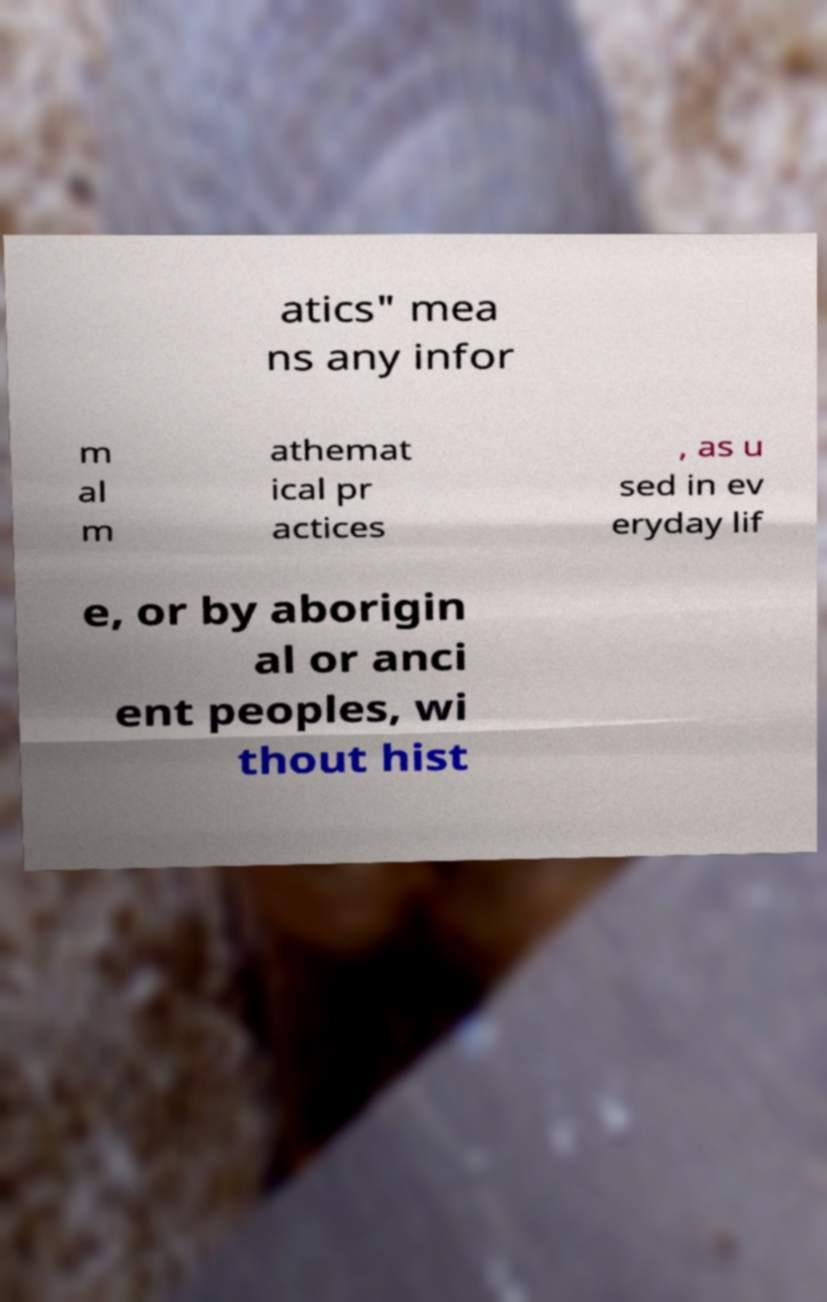There's text embedded in this image that I need extracted. Can you transcribe it verbatim? atics" mea ns any infor m al m athemat ical pr actices , as u sed in ev eryday lif e, or by aborigin al or anci ent peoples, wi thout hist 